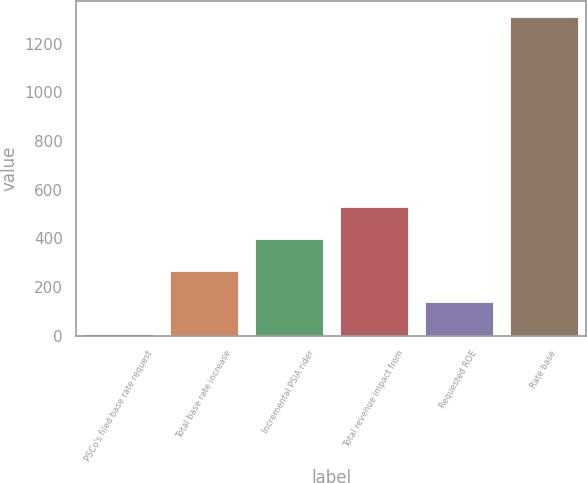Convert chart. <chart><loc_0><loc_0><loc_500><loc_500><bar_chart><fcel>PSCo's filed base rate request<fcel>Total base rate increase<fcel>Incremental PSIA rider<fcel>Total revenue impact from<fcel>Requested ROE<fcel>Rate base<nl><fcel>7.6<fcel>268.08<fcel>398.32<fcel>528.56<fcel>137.84<fcel>1310<nl></chart> 